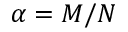<formula> <loc_0><loc_0><loc_500><loc_500>\alpha = M / N</formula> 